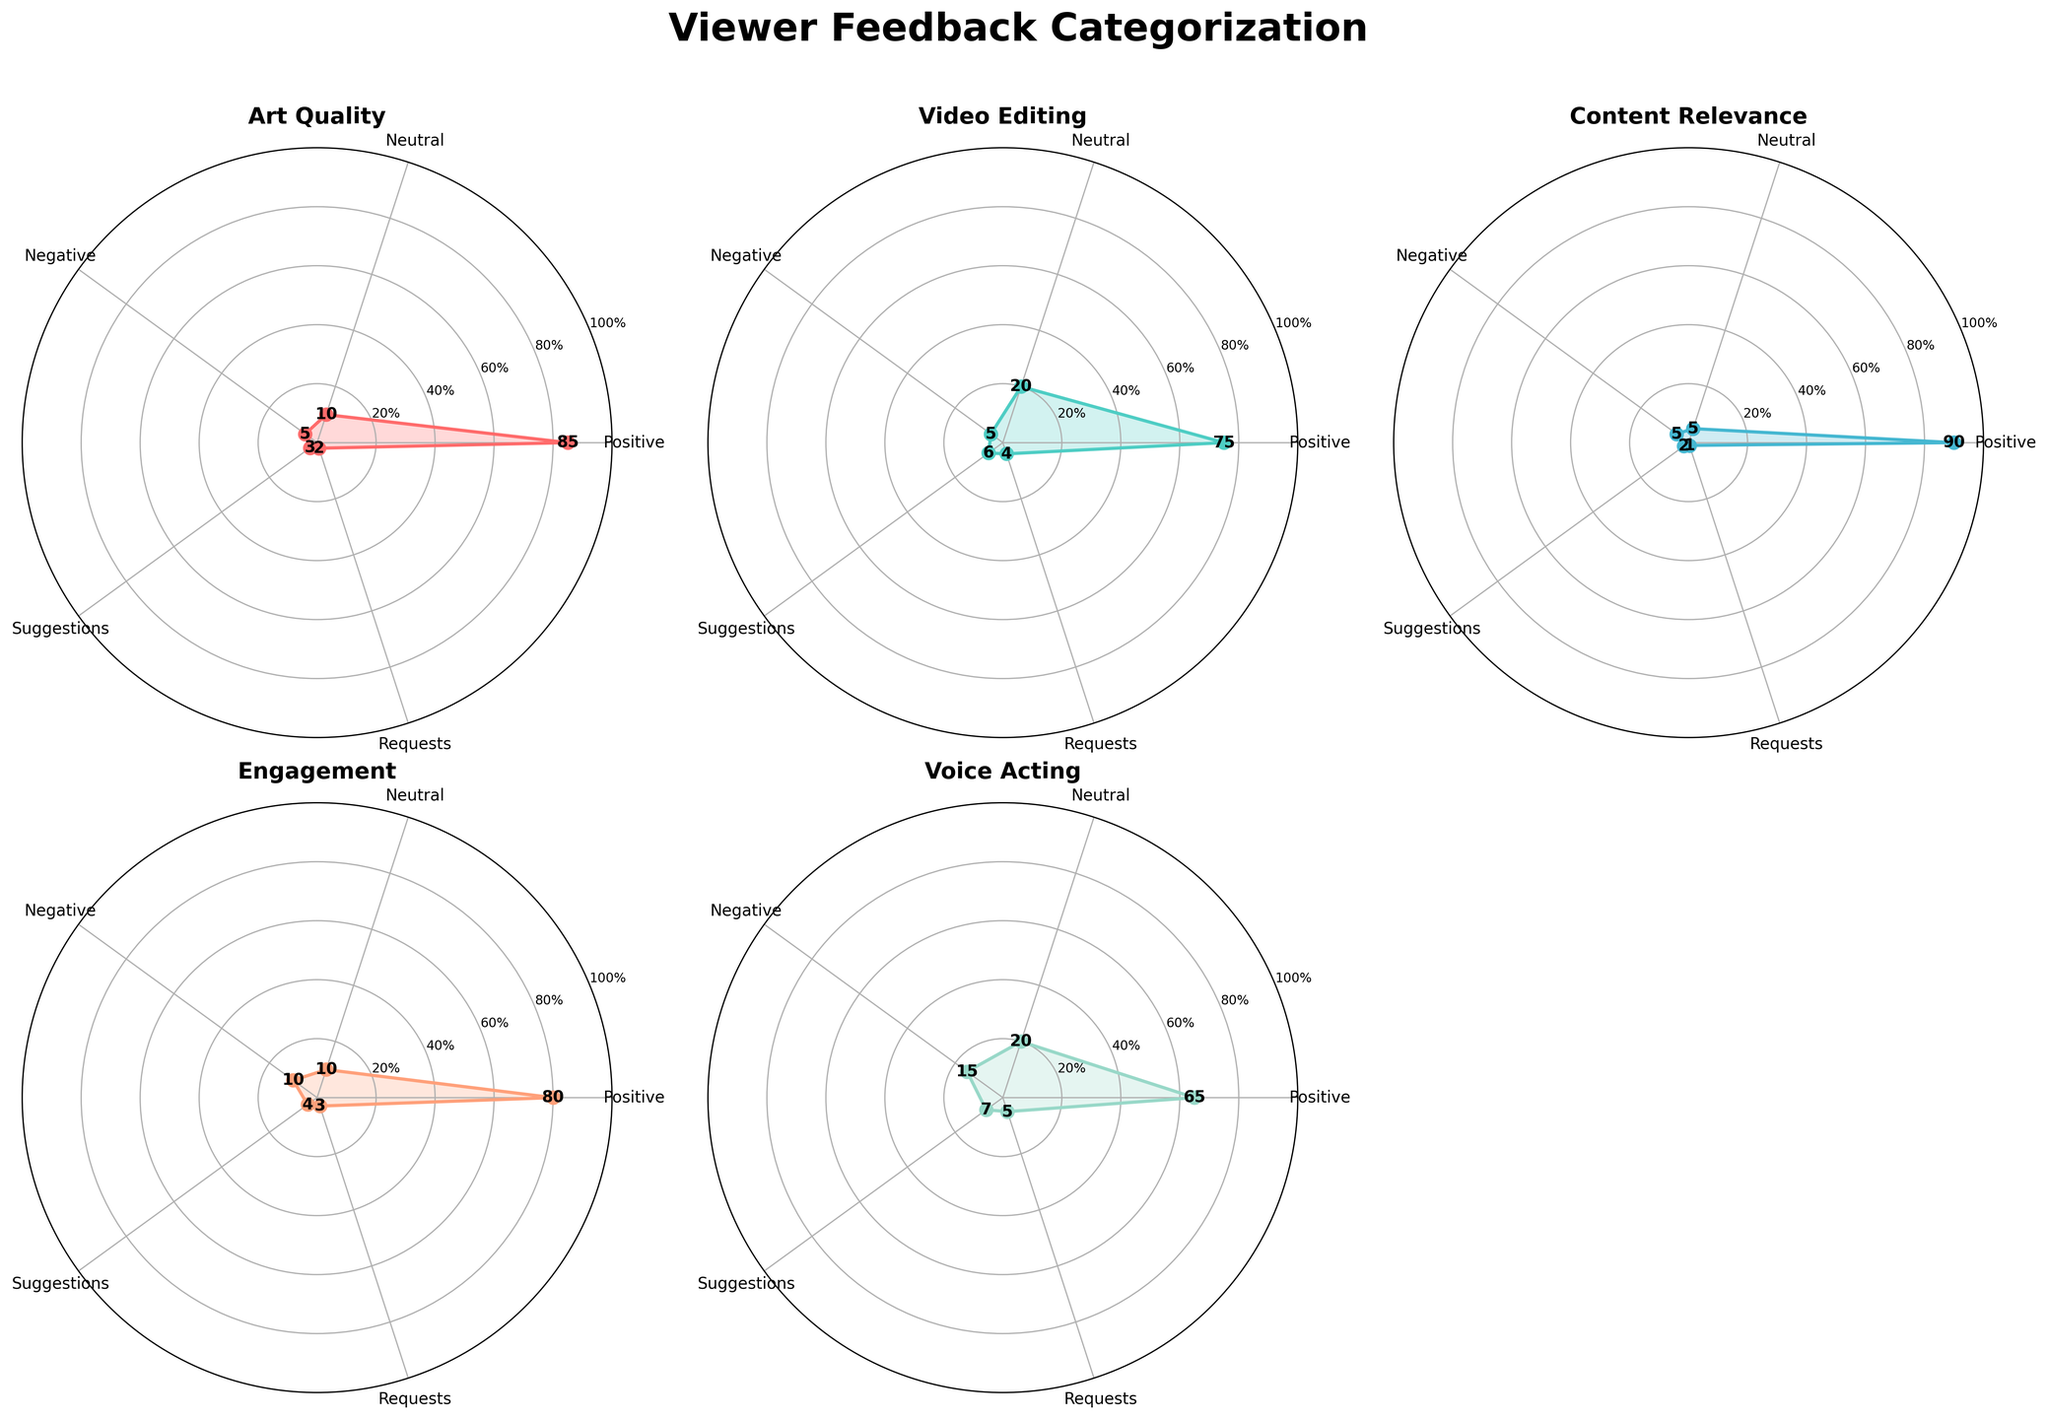What's the title of the figure? The title is located at the top center of the figure. It reads "Viewer Feedback Categorization".
Answer: Viewer Feedback Categorization Which category has the highest positive feedback? To answer this, look at the values for positive feedback for each category. The highest value among them is for Content Relevance, with 90.
Answer: Content Relevance Which category has the most negative feedback? Check the values for negative feedback across all categories. Voice Acting stands out with the highest negative feedback of 15.
Answer: Voice Acting What is the average positive feedback for all categories? Sum the positive feedback values (85 + 75 + 90 + 80 + 65 + 88) = 483, then divide by the number of categories, which is 6. So, 483/6 = 80.5.
Answer: 80.5 Which category has the smallest difference between positive and negative feedback? Calculate the difference between positive and negative feedback for each category. The differences are as follows: Art Quality (80), Video Editing (70), Content Relevance (85), Engagement (70), Voice Acting (50), Character Design (83). The smallest difference is for Voice Acting, with a difference of 50.
Answer: Voice Acting Does any category have exactly equal neutral and negative feedback? Compare the neutral and negative feedback values for each category. No category has exactly equal values for neutral and negative feedback.
Answer: No Which category has the highest number of requests? Look at the values for requests across all categories. Voice Acting has the highest, with 5 requests.
Answer: Voice Acting Is the engagement feedback more positive than negative? Check the values for positive and negative feedback under Engagement. Positive is 80 and negative is 10, so yes, Engagement is more positive.
Answer: Yes Which attribute has the lowest average feedback across all categories? Calculate the average value for each attribute: Positive (483/6 = 80.5), Neutral (72/6 = 12), Negative (45/6 = 7.5), Suggestions (25/6 = ~4.17), Requests (17/6 = ~2.83). Requests have the lowest average of around 2.83.
Answer: Requests What is the total number of feedback entries (all types) for Character Design? Sum all feedback entries for Character Design: 88 (Positive) + 7 (Neutral) + 5 (Negative) + 3 (Suggestions) + 2 (Requests) = 105.
Answer: 105 